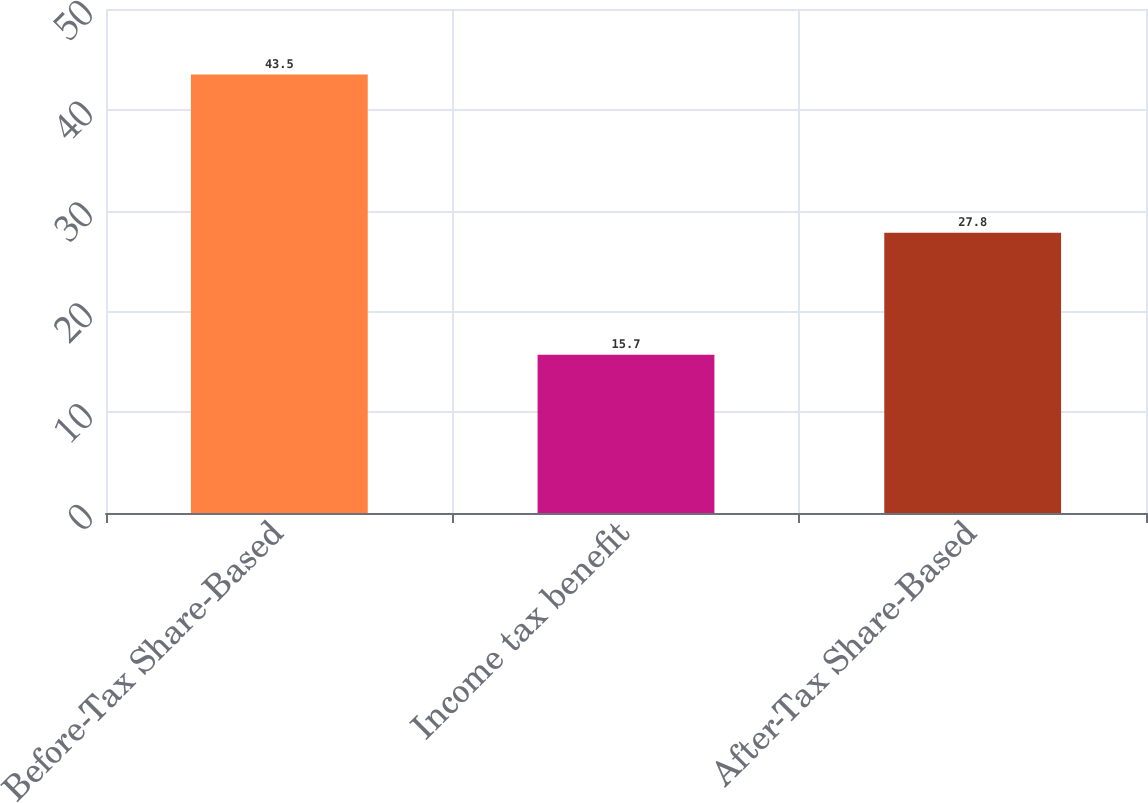<chart> <loc_0><loc_0><loc_500><loc_500><bar_chart><fcel>Before-Tax Share-Based<fcel>Income tax benefit<fcel>After-Tax Share-Based<nl><fcel>43.5<fcel>15.7<fcel>27.8<nl></chart> 